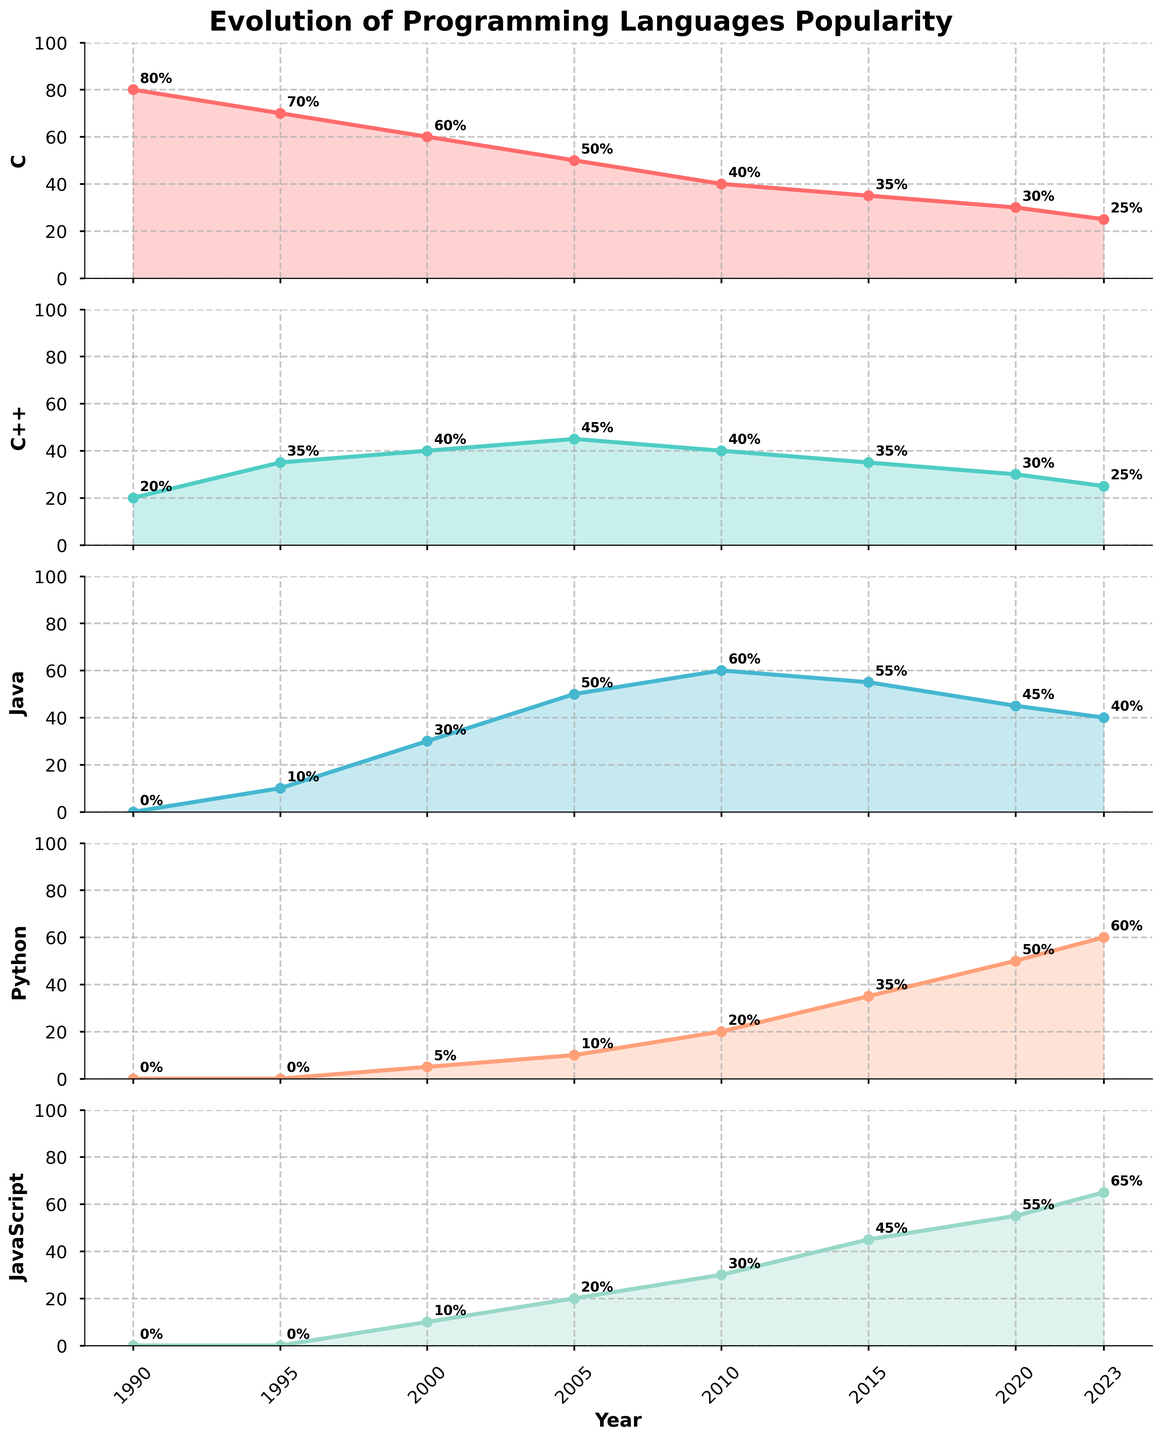What is the title of the figure? The title of the figure is given at the top and reads "Evolution of Programming Languages Popularity".
Answer: Evolution of Programming Languages Popularity How many subplots are there in the figure? There are five distinct line plots vertically aligned; these represent the five subplots.
Answer: 5 What color represents the popularity of Python? The color representing Python can be identified by looking at the line and fill color corresponding to the subplot labeled "Python." It is a salmon-like color.
Answer: Salmon-like What was the popularity of Java in the year 2000? By finding the year 2000 on the x-axis of the Java subplot, we can see that the popularity value annotated is 30%.
Answer: 30% Which programming language had the highest popularity in 1990? Reviewing the annotations for 1990 in each subplot, the highest value is for "C," which is 80%.
Answer: C Between 1995 and 2023, which language shows the most consistent increase in popularity? Comparing the slopes of the lines across all subplots, Python demonstrates the most consistent increase as it steadily rises from 0% in 1995 to 60% in 2023.
Answer: Python In 2020, which programming language had almost the same popularity? By locating the year 2020 on the x-axis and comparing the annotated values on different subplots, "C" and "C++" both had popularity values of 30%.
Answer: C and C++ How has the popularity of JavaScript changed from 1990 to 2023? Observing the JavaScript subplot, we can see that the popularity increased from 0% in 1990 to 65% in 2023.
Answer: Increased from 0% to 65% Which two languages had a crossing point in their popularity trends, and around what year did this occur? Looking for intersecting values, Java and Python cross around between the years 2015 and 2020, evident by the close values and trend lines of these two subplots.
Answer: Java and Python, around 2020 